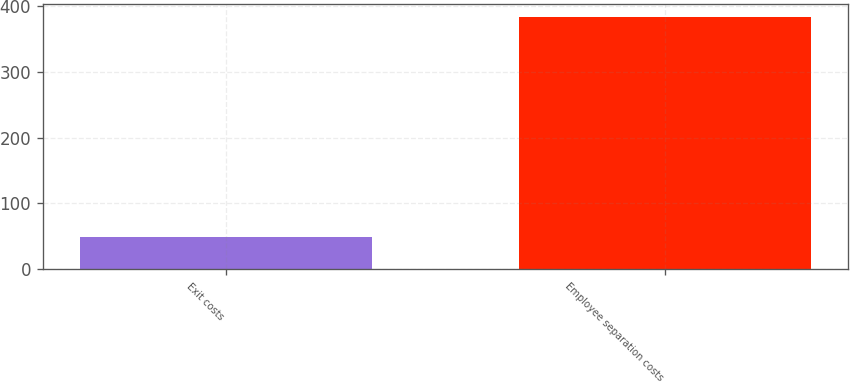Convert chart. <chart><loc_0><loc_0><loc_500><loc_500><bar_chart><fcel>Exit costs<fcel>Employee separation costs<nl><fcel>49<fcel>383<nl></chart> 